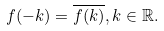Convert formula to latex. <formula><loc_0><loc_0><loc_500><loc_500>f ( - k ) = \overline { f ( k ) } , k \in \mathbb { R } .</formula> 